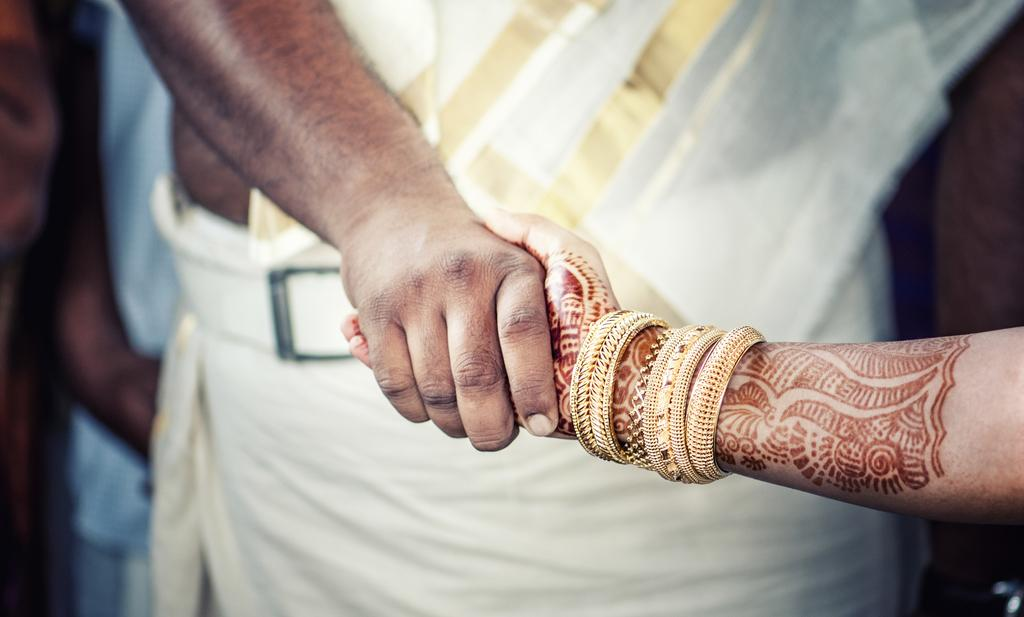How many people are in the image? There are two people in the image, a man and a woman. What are the man and woman doing in the image? The man and woman are standing and holding their hands. Can you describe the relationship between the man and woman in the image? The man and woman are holding hands, which may suggest a close relationship or connection. What type of curve can be seen in the image? There is no curve present in the image; it features a man and a woman standing and holding hands. Can you tell me how many keys the beggar is holding in the image? There is no beggar present in the image, nor are there any keys visible. 